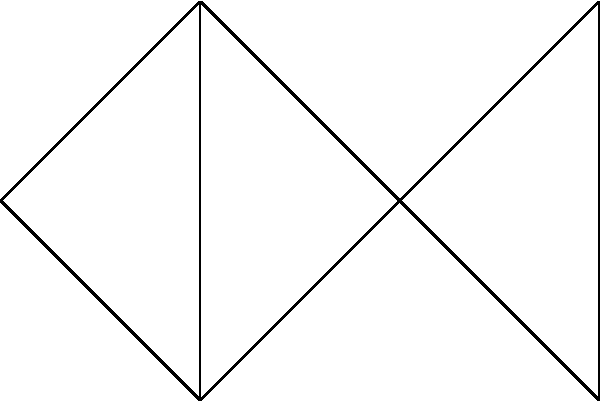In the network graph representing online publications and their relationships, what is the minimum number of publications that need to be removed to disconnect publication P5 from publication P6? To answer this question, we need to analyze the connectivity between P5 and P6 in the given network graph. Let's follow these steps:

1. Identify the nodes representing P5 and P6:
   P5 is the upper-right node, and P6 is the lower-right node.

2. Observe the connections between P5 and P6:
   P5 and P6 are directly connected to each other.
   They are also both connected to P3 (the middle-right node).

3. Analyze the paths between P5 and P6:
   - Direct path: P5 -- P6
   - Indirect path: P5 -- P3 -- P6

4. Determine the minimum number of publications to remove:
   To disconnect P5 from P6, we need to remove both:
   a) The direct connection between P5 and P6
   b) The common node they are both connected to (P3)

5. Count the number of publications to remove:
   We need to remove 1 publication (P3) to disconnect P5 from P6.

By removing P3, we eliminate both the direct and indirect paths between P5 and P6, effectively disconnecting them in the network.
Answer: 1 